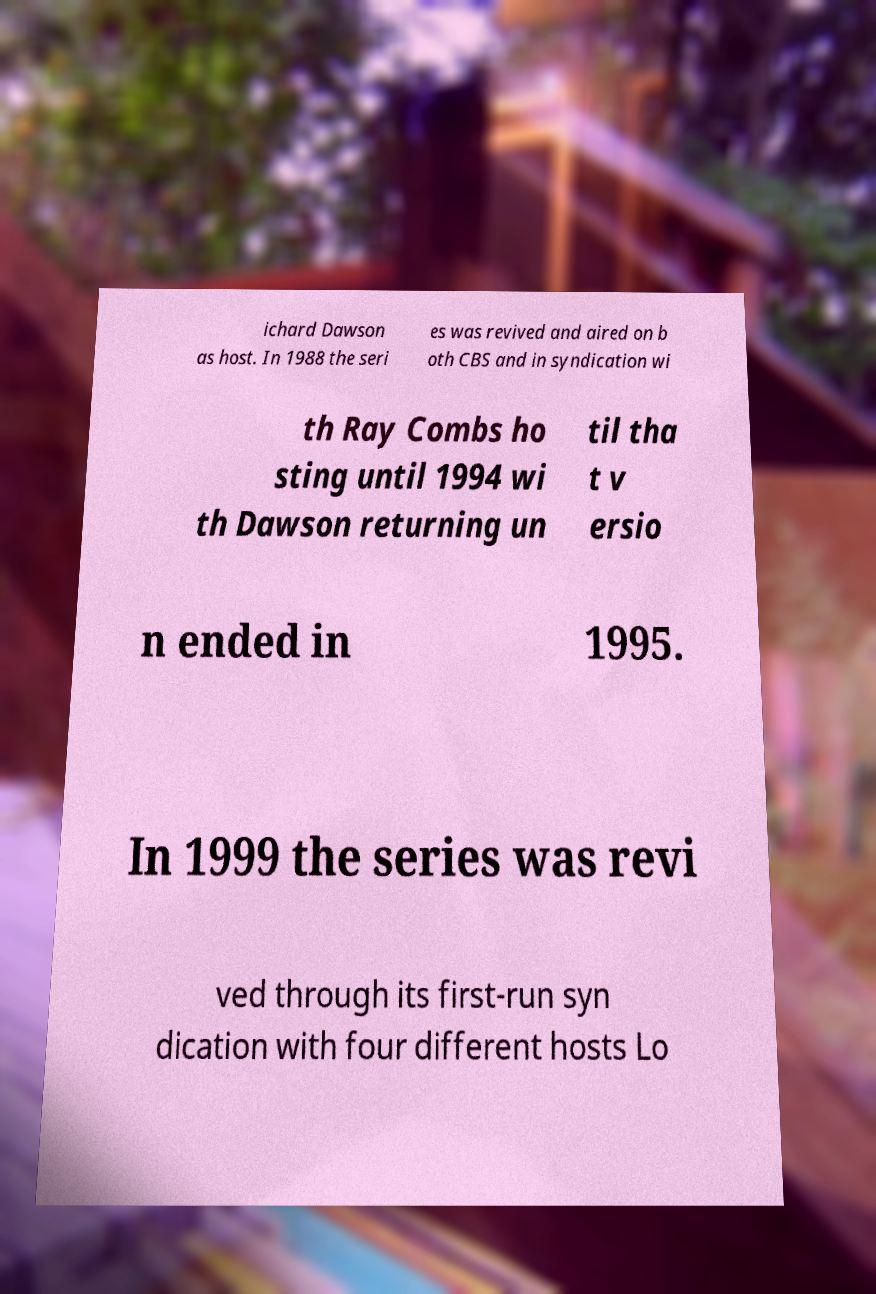Could you extract and type out the text from this image? ichard Dawson as host. In 1988 the seri es was revived and aired on b oth CBS and in syndication wi th Ray Combs ho sting until 1994 wi th Dawson returning un til tha t v ersio n ended in 1995. In 1999 the series was revi ved through its first-run syn dication with four different hosts Lo 